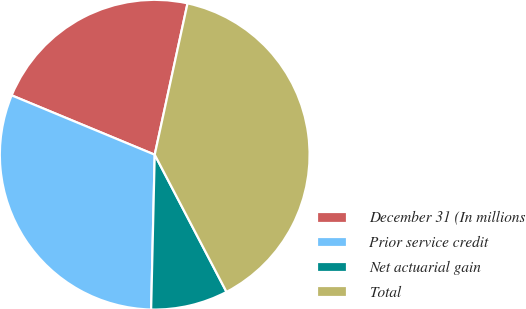Convert chart to OTSL. <chart><loc_0><loc_0><loc_500><loc_500><pie_chart><fcel>December 31 (In millions<fcel>Prior service credit<fcel>Net actuarial gain<fcel>Total<nl><fcel>22.14%<fcel>30.89%<fcel>8.04%<fcel>38.93%<nl></chart> 